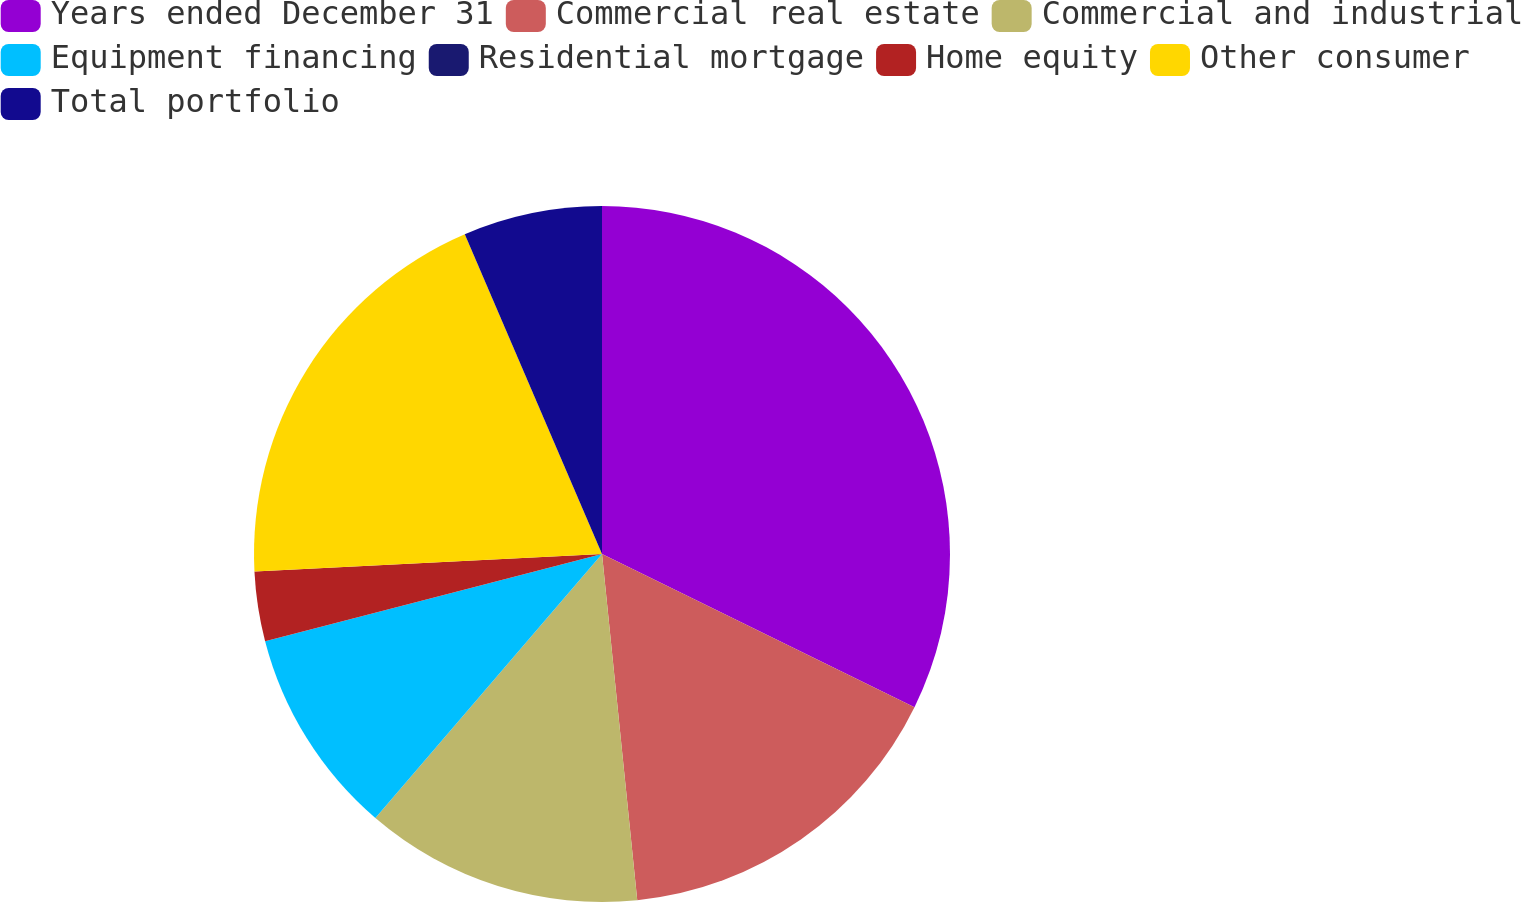Convert chart to OTSL. <chart><loc_0><loc_0><loc_500><loc_500><pie_chart><fcel>Years ended December 31<fcel>Commercial real estate<fcel>Commercial and industrial<fcel>Equipment financing<fcel>Residential mortgage<fcel>Home equity<fcel>Other consumer<fcel>Total portfolio<nl><fcel>32.25%<fcel>16.13%<fcel>12.9%<fcel>9.68%<fcel>0.0%<fcel>3.23%<fcel>19.35%<fcel>6.45%<nl></chart> 